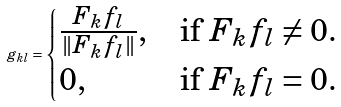Convert formula to latex. <formula><loc_0><loc_0><loc_500><loc_500>g _ { k l } = \begin{cases} \frac { F _ { k } f _ { l } } { \| F _ { k } f _ { l } \| } , & \text {if $F_{k}f_{l}\neq 0.$} \\ 0 , & \text {if $ F_{k}f_{l}=0$.} \end{cases}</formula> 